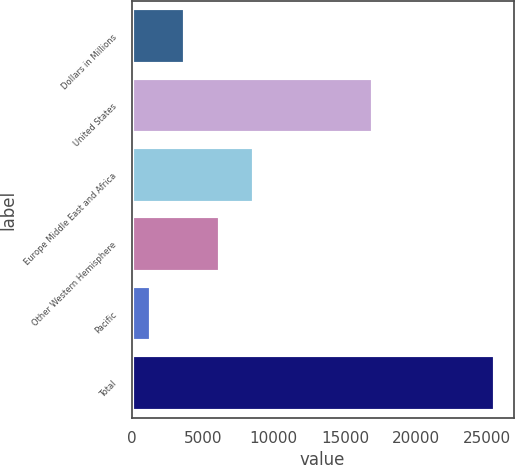Convert chart to OTSL. <chart><loc_0><loc_0><loc_500><loc_500><bar_chart><fcel>Dollars in Millions<fcel>United States<fcel>Europe Middle East and Africa<fcel>Other Western Hemisphere<fcel>Pacific<fcel>Total<nl><fcel>3785.1<fcel>16942<fcel>8627.3<fcel>6206.2<fcel>1364<fcel>25575<nl></chart> 